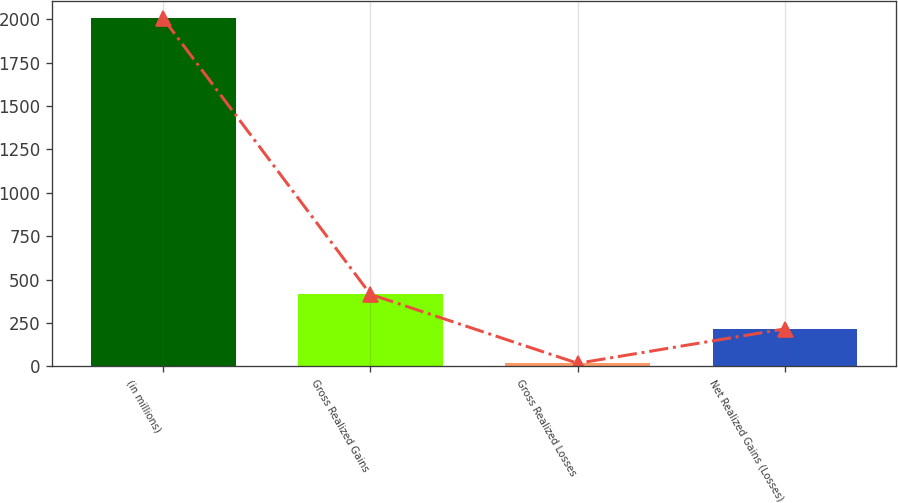Convert chart to OTSL. <chart><loc_0><loc_0><loc_500><loc_500><bar_chart><fcel>(in millions)<fcel>Gross Realized Gains<fcel>Gross Realized Losses<fcel>Net Realized Gains (Losses)<nl><fcel>2004<fcel>415.2<fcel>18<fcel>216.6<nl></chart> 